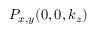Convert formula to latex. <formula><loc_0><loc_0><loc_500><loc_500>P _ { x , y } ( 0 , 0 , k _ { z } )</formula> 